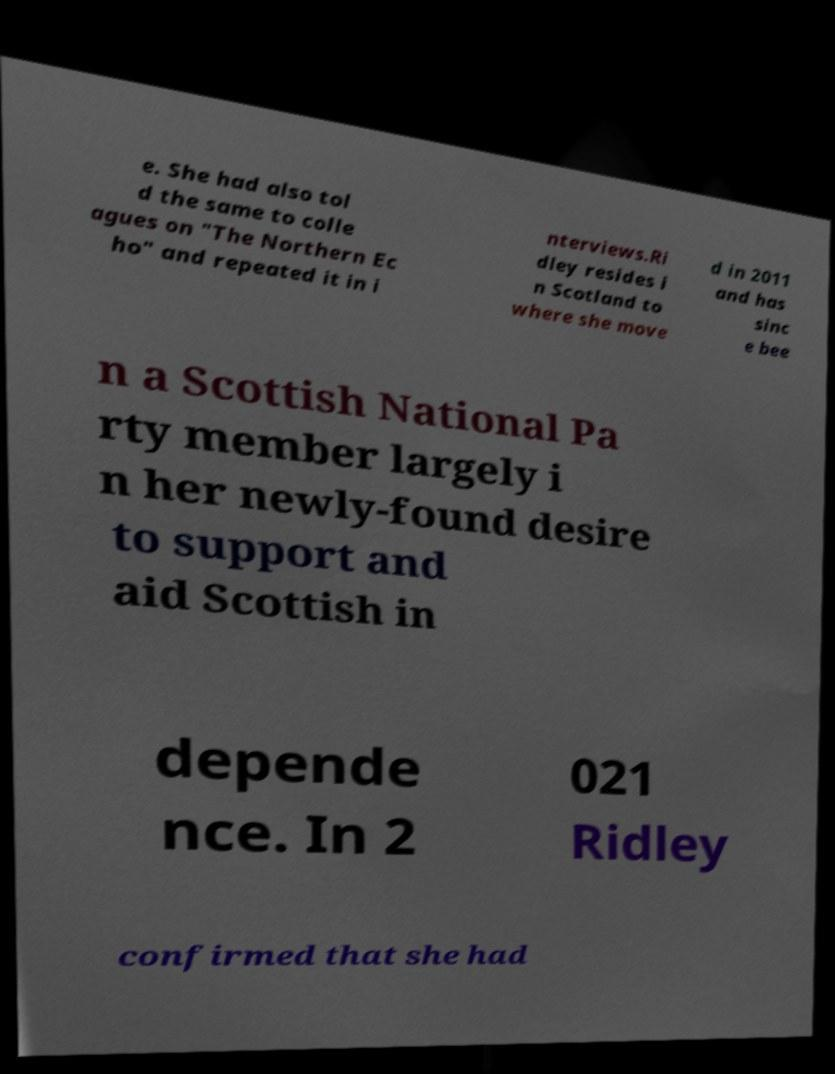Can you read and provide the text displayed in the image?This photo seems to have some interesting text. Can you extract and type it out for me? e. She had also tol d the same to colle agues on "The Northern Ec ho" and repeated it in i nterviews.Ri dley resides i n Scotland to where she move d in 2011 and has sinc e bee n a Scottish National Pa rty member largely i n her newly-found desire to support and aid Scottish in depende nce. In 2 021 Ridley confirmed that she had 